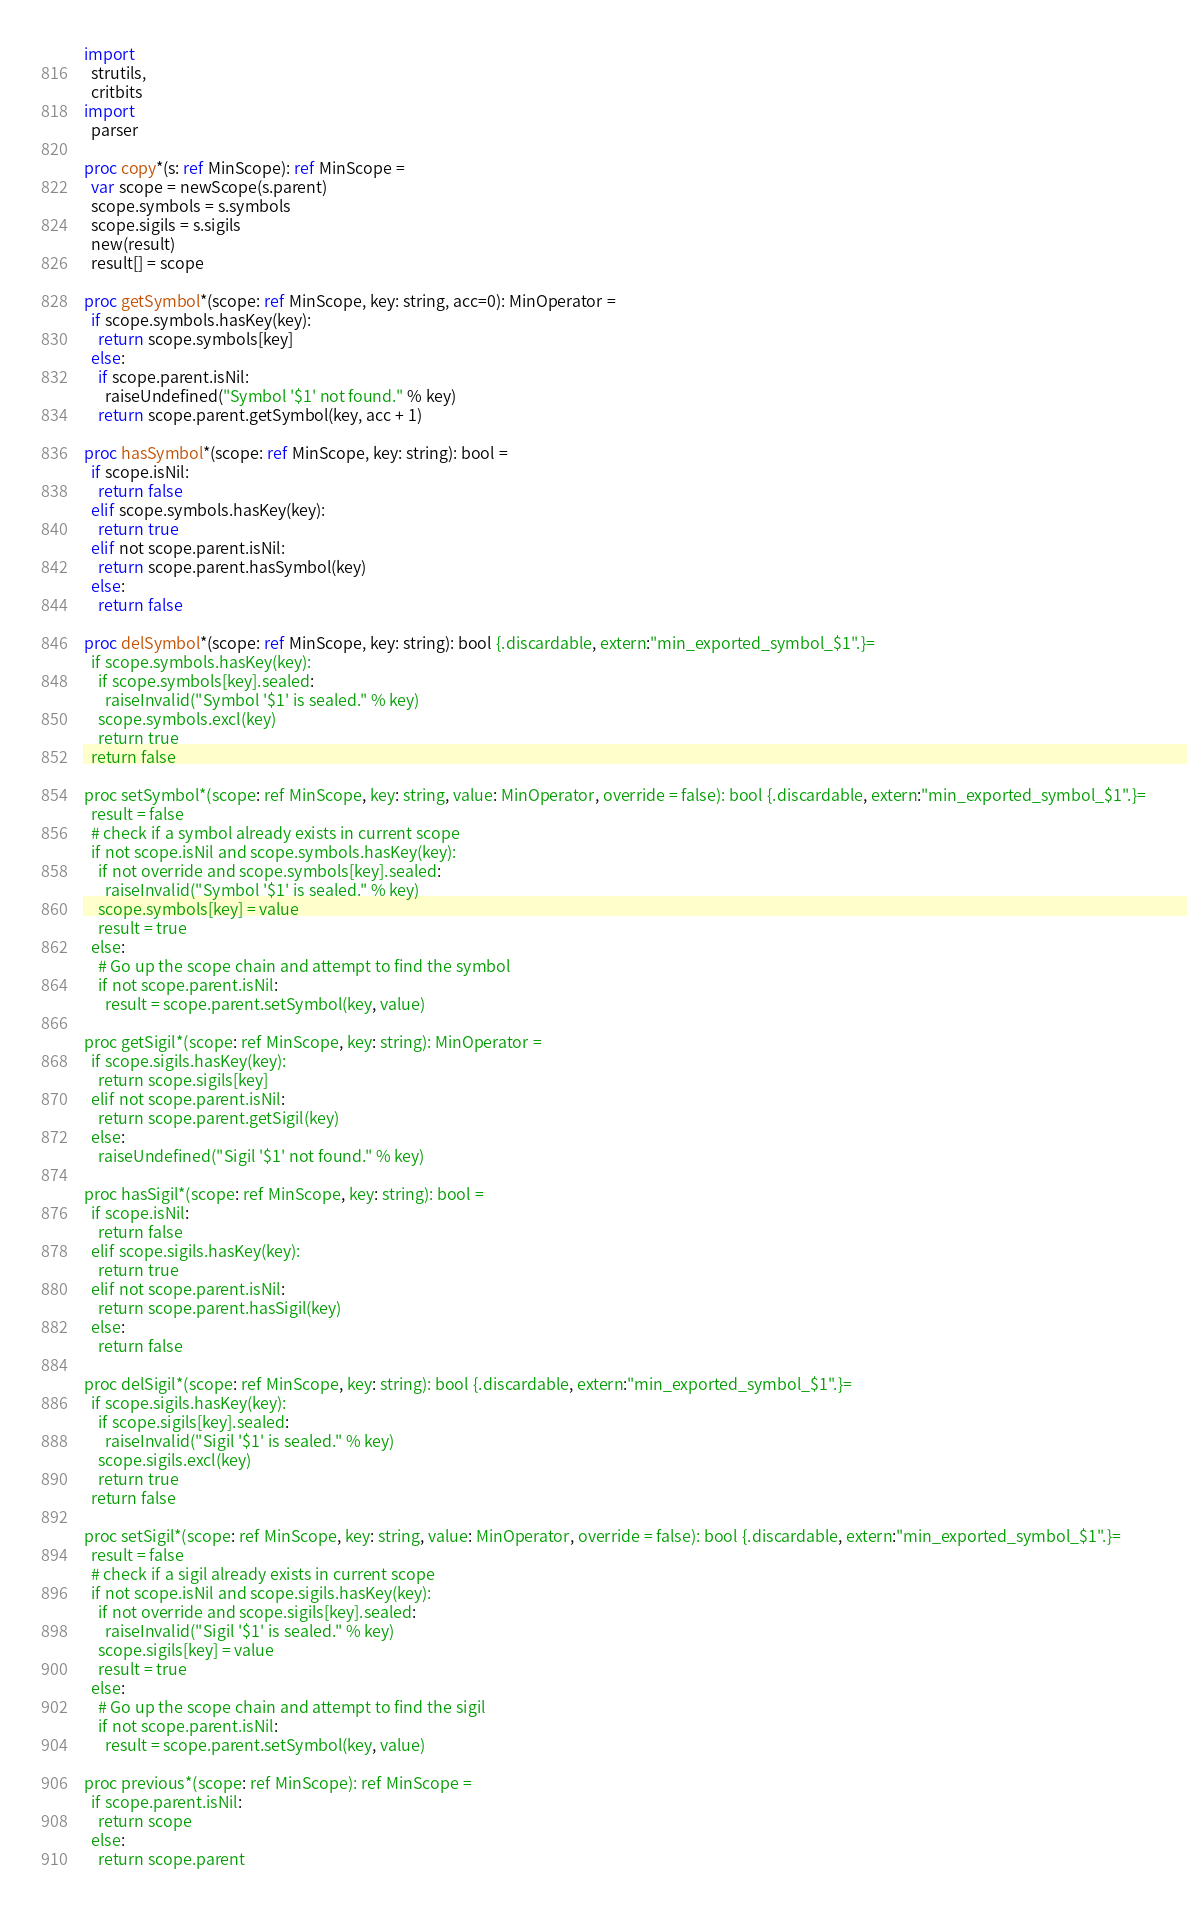Convert code to text. <code><loc_0><loc_0><loc_500><loc_500><_Nim_>import
  strutils,
  critbits
import
  parser

proc copy*(s: ref MinScope): ref MinScope =
  var scope = newScope(s.parent)
  scope.symbols = s.symbols
  scope.sigils = s.sigils
  new(result)
  result[] = scope
  
proc getSymbol*(scope: ref MinScope, key: string, acc=0): MinOperator =
  if scope.symbols.hasKey(key):
    return scope.symbols[key]
  else:
    if scope.parent.isNil:
      raiseUndefined("Symbol '$1' not found." % key)
    return scope.parent.getSymbol(key, acc + 1)

proc hasSymbol*(scope: ref MinScope, key: string): bool =
  if scope.isNil:
    return false
  elif scope.symbols.hasKey(key):
    return true
  elif not scope.parent.isNil:
    return scope.parent.hasSymbol(key)
  else:
    return false

proc delSymbol*(scope: ref MinScope, key: string): bool {.discardable, extern:"min_exported_symbol_$1".}=
  if scope.symbols.hasKey(key):
    if scope.symbols[key].sealed:
      raiseInvalid("Symbol '$1' is sealed." % key) 
    scope.symbols.excl(key)
    return true
  return false

proc setSymbol*(scope: ref MinScope, key: string, value: MinOperator, override = false): bool {.discardable, extern:"min_exported_symbol_$1".}=
  result = false
  # check if a symbol already exists in current scope
  if not scope.isNil and scope.symbols.hasKey(key):
    if not override and scope.symbols[key].sealed:
      raiseInvalid("Symbol '$1' is sealed." % key) 
    scope.symbols[key] = value
    result = true
  else:
    # Go up the scope chain and attempt to find the symbol
    if not scope.parent.isNil:
      result = scope.parent.setSymbol(key, value)

proc getSigil*(scope: ref MinScope, key: string): MinOperator =
  if scope.sigils.hasKey(key):
    return scope.sigils[key]
  elif not scope.parent.isNil:
    return scope.parent.getSigil(key)
  else:
    raiseUndefined("Sigil '$1' not found." % key)

proc hasSigil*(scope: ref MinScope, key: string): bool =
  if scope.isNil:
    return false
  elif scope.sigils.hasKey(key):
    return true
  elif not scope.parent.isNil:
    return scope.parent.hasSigil(key)
  else:
    return false

proc delSigil*(scope: ref MinScope, key: string): bool {.discardable, extern:"min_exported_symbol_$1".}=
  if scope.sigils.hasKey(key):
    if scope.sigils[key].sealed:
      raiseInvalid("Sigil '$1' is sealed." % key) 
    scope.sigils.excl(key)
    return true
  return false

proc setSigil*(scope: ref MinScope, key: string, value: MinOperator, override = false): bool {.discardable, extern:"min_exported_symbol_$1".}=
  result = false
  # check if a sigil already exists in current scope
  if not scope.isNil and scope.sigils.hasKey(key):
    if not override and scope.sigils[key].sealed:
      raiseInvalid("Sigil '$1' is sealed." % key) 
    scope.sigils[key] = value
    result = true
  else:
    # Go up the scope chain and attempt to find the sigil
    if not scope.parent.isNil:
      result = scope.parent.setSymbol(key, value)

proc previous*(scope: ref MinScope): ref MinScope =
  if scope.parent.isNil:
    return scope 
  else:
    return scope.parent</code> 